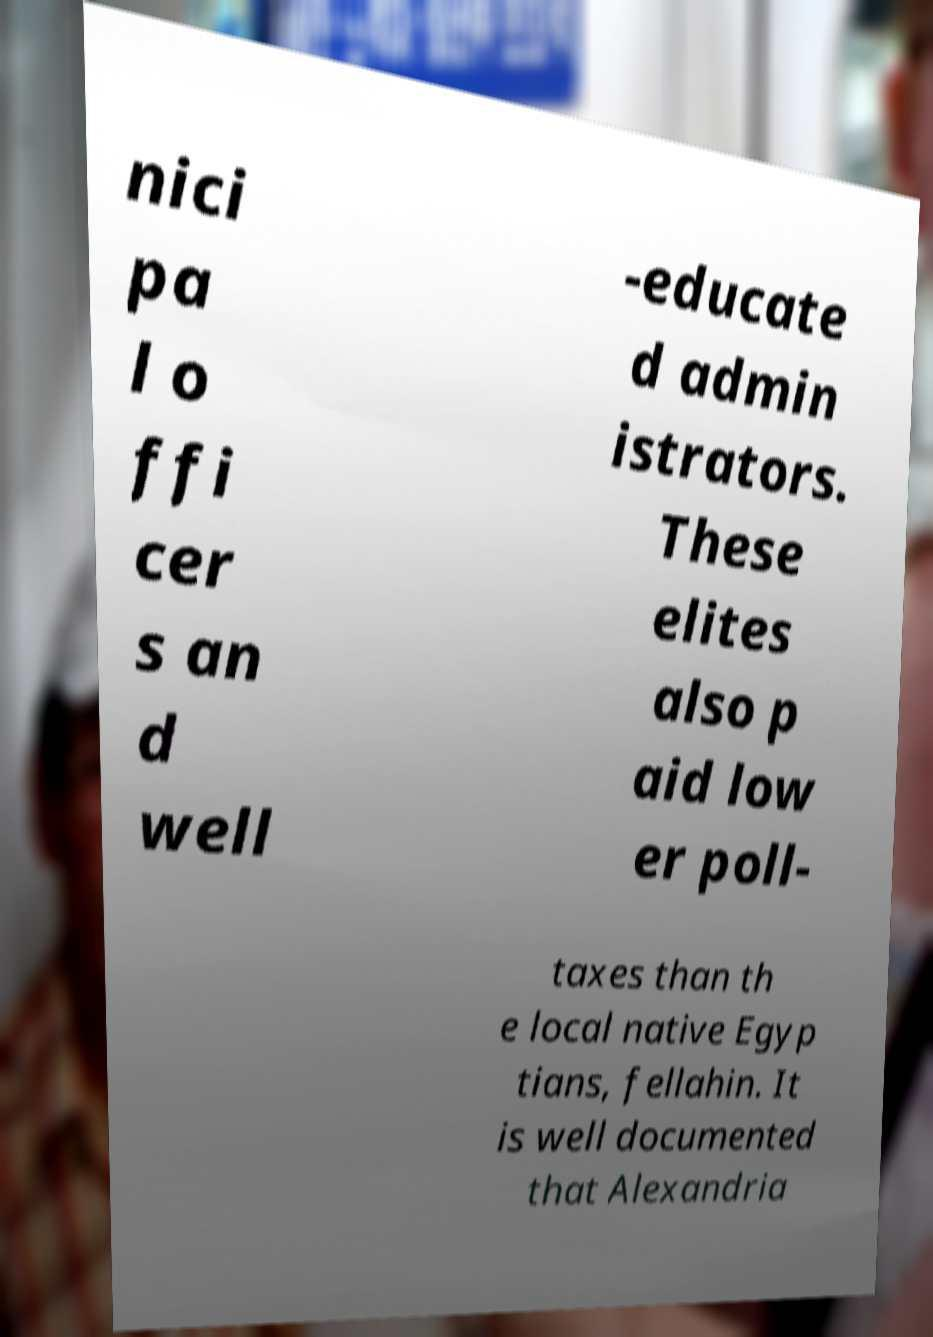For documentation purposes, I need the text within this image transcribed. Could you provide that? nici pa l o ffi cer s an d well -educate d admin istrators. These elites also p aid low er poll- taxes than th e local native Egyp tians, fellahin. It is well documented that Alexandria 